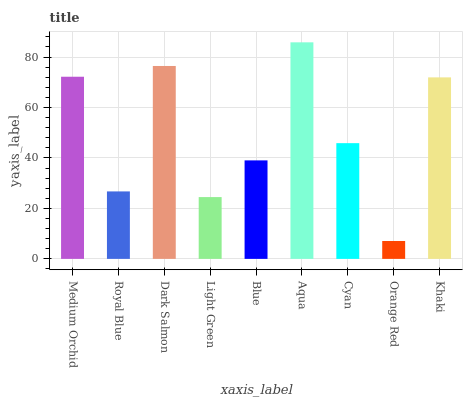Is Orange Red the minimum?
Answer yes or no. Yes. Is Aqua the maximum?
Answer yes or no. Yes. Is Royal Blue the minimum?
Answer yes or no. No. Is Royal Blue the maximum?
Answer yes or no. No. Is Medium Orchid greater than Royal Blue?
Answer yes or no. Yes. Is Royal Blue less than Medium Orchid?
Answer yes or no. Yes. Is Royal Blue greater than Medium Orchid?
Answer yes or no. No. Is Medium Orchid less than Royal Blue?
Answer yes or no. No. Is Cyan the high median?
Answer yes or no. Yes. Is Cyan the low median?
Answer yes or no. Yes. Is Royal Blue the high median?
Answer yes or no. No. Is Blue the low median?
Answer yes or no. No. 